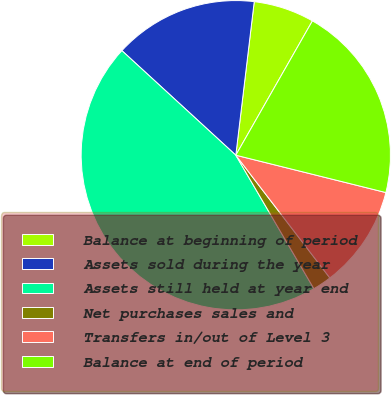Convert chart. <chart><loc_0><loc_0><loc_500><loc_500><pie_chart><fcel>Balance at beginning of period<fcel>Assets sold during the year<fcel>Assets still held at year end<fcel>Net purchases sales and<fcel>Transfers in/out of Level 3<fcel>Balance at end of period<nl><fcel>6.35%<fcel>15.08%<fcel>45.24%<fcel>1.98%<fcel>10.71%<fcel>20.63%<nl></chart> 